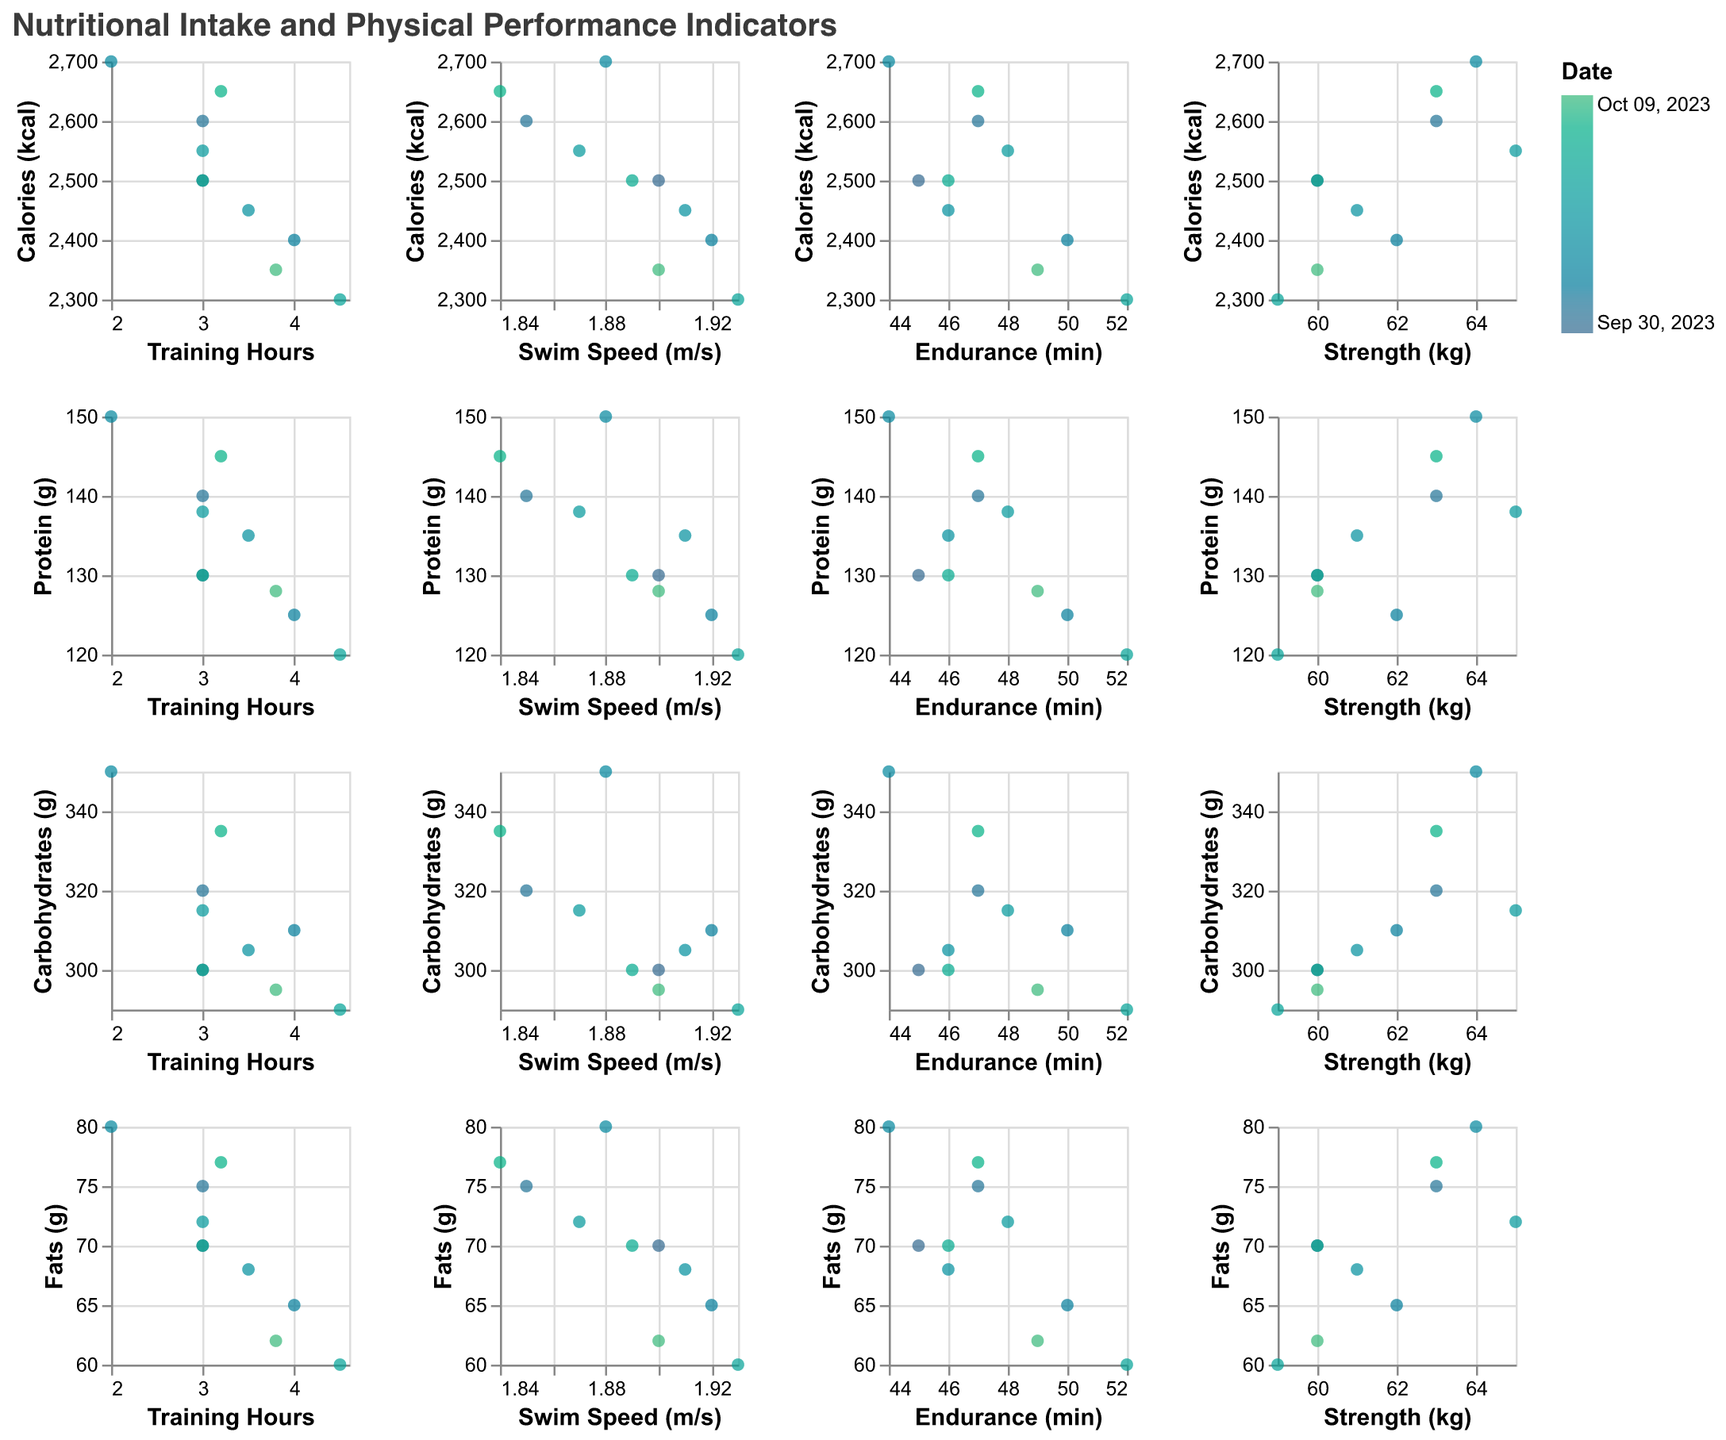What is the relationship between Training Hours and Swim Speed? Observe the scatter plot between "Training Hours" and "Swim Speed (m/s)". Look for any visible upward or downward trend. The points appear scattered, indicating no clear correlation.
Answer: No clear relationship Which data point shows the highest Training Hours? Examine the x-axis of all "Training Hours" scatter plots. The highest x-value should indicate the highest training hours. "2023-10-07" has the highest value at 4.5 hours.
Answer: 2023-10-07 Is there a noticeable correlation between Protein intake and Strength? Check the scatter plot between "Protein (g)" and "Strength (kg)". The points seem scattered without a clear upward or downward trend, indicating no noticeable correlation.
Answer: No noticeable correlation On which date is the Swim Speed highest? Identify the data point with the highest y-value in any "Swim Speed (m/s)" scatter plot. "2023-10-07" has the highest swim speed at 1.93 m/s.
Answer: 2023-10-07 What trend can be observed between Carbohydrates and Endurance? Examine the scatter plot between "Carbohydrates (g)" and "Endurance (min)". Higher carbohydrate intake appears to correlate with longer endurance times.
Answer: Positive trend How does Fats intake affect Swim Speed? Look at the scatter plot between "Fats (g)" and "Swim Speed (m/s)". The points do not show a strong upward or downward trend, indicating little to no visible correlation.
Answer: Little to no correlation Which combination of nutrient intake and physical performance indicator seems the most correlated? Compare all scatter plots to identify the ones with a clear trend. "Carbohydrates (g)" and "Endurance (min)" shows a positive trend, indicating the most obvious correlation among the pairs.
Answer: Carbohydrates and Endurance What is the average Swim Speed observed over the entire period? Add up the swim speeds: 1.9 + 1.85 + 1.92 + 1.88 + 1.91 + 1.87 + 1.93 + 1.89 + 1.84 + 1.9 = 18.89. Divide by the number of data points (10). The average swim speed is 18.89/10 = 1.889.
Answer: 1.889 m/s Is there a correlation between Calories intake and Strength? Examine the scatter plot between "Calories (kcal)" and "Strength (kg)". The points seem scattered without a clear upward or downward trend, indicating no noticeable correlation.
Answer: No noticeable correlation 